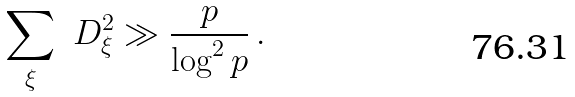Convert formula to latex. <formula><loc_0><loc_0><loc_500><loc_500>\sum _ { \xi } \ D ^ { 2 } _ { \xi } \gg \frac { p } { \log ^ { 2 } p } \, .</formula> 